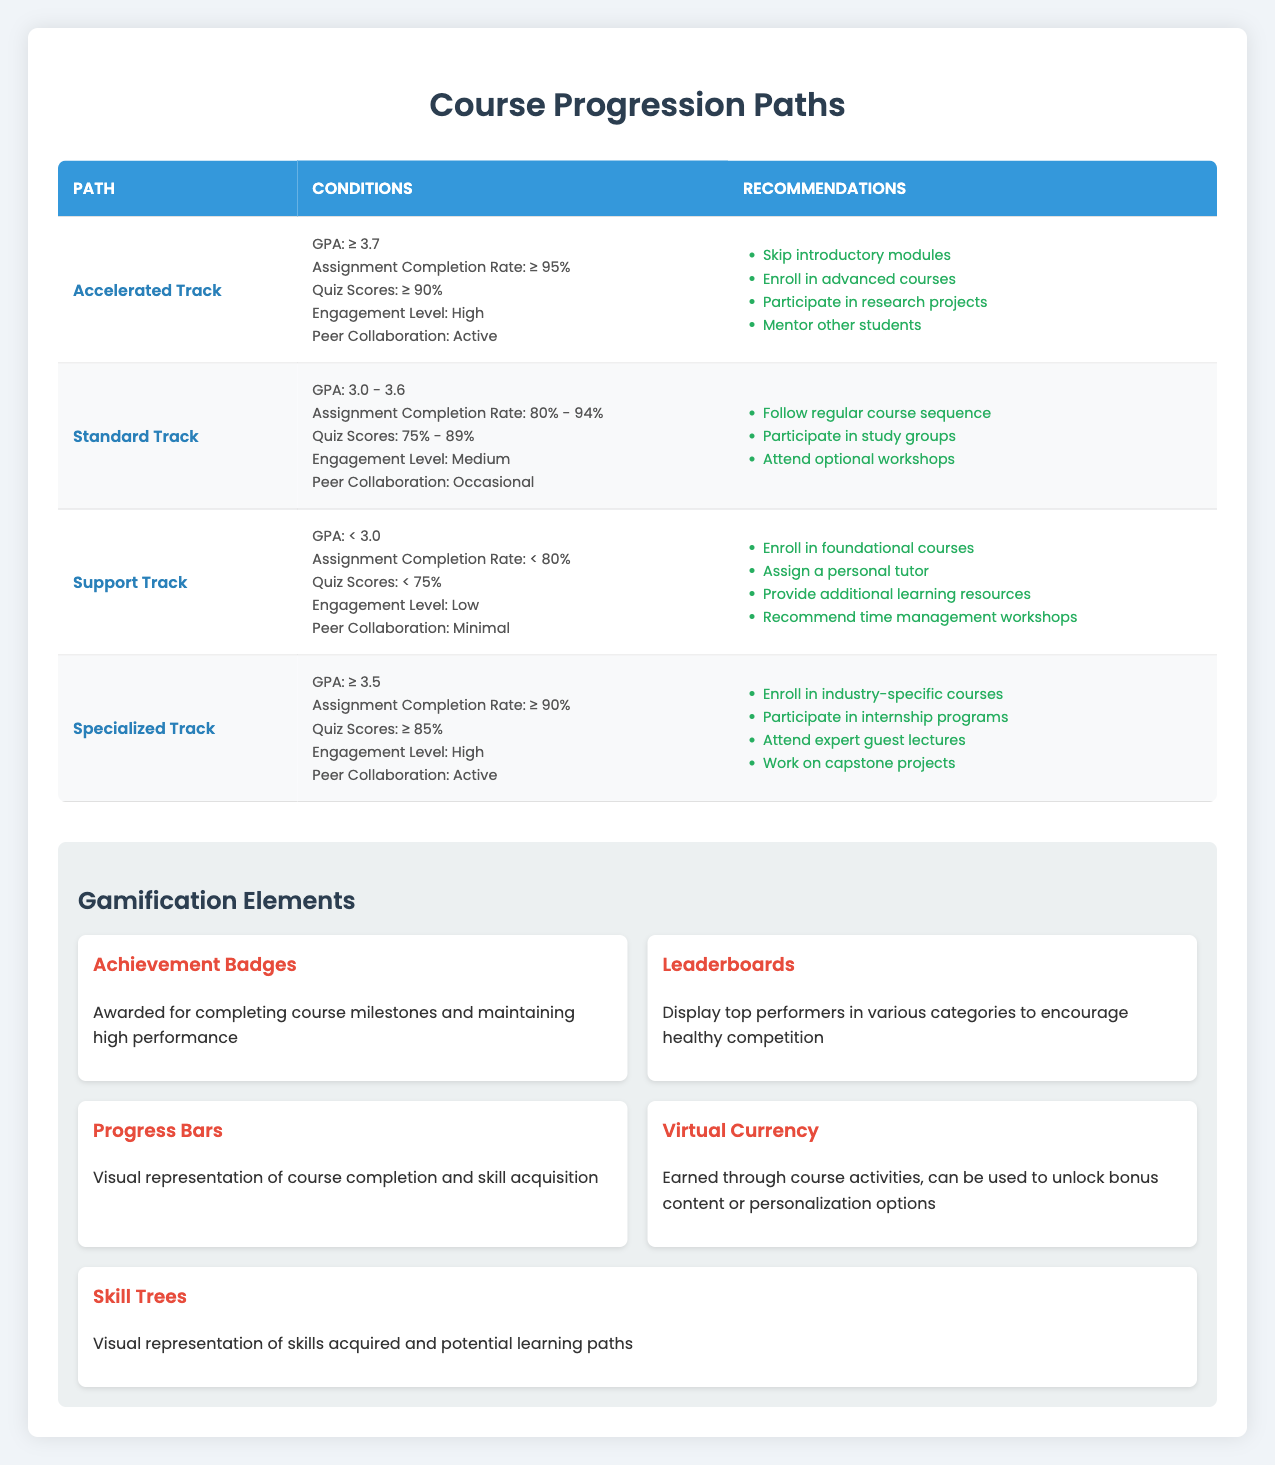What are the conditions for the Support Track? The conditions for the Support Track include a GPA of less than 3.0, an Assignment Completion Rate of less than 80%, Quiz Scores below 75%, a Low Engagement Level, and Minimal Peer Collaboration. These conditions can be easily found in the table under the Support Track row.
Answer: GPA: < 3.0, Assignment Completion Rate: < 80%, Quiz Scores: < 75%, Engagement Level: Low, Peer Collaboration: Minimal Which track has the highest GPA requirement? Looking at the table, the Accelerated Track has a GPA requirement of 3.7 or higher, while the Specialized Track requires a GPA of at least 3.5. The Support Track has a lower threshold of less than 3.0. Therefore, the Accelerated Track has the highest GPA requirement.
Answer: Accelerated Track Is Active Peer Collaboration a condition for the Standard Track? Referring to the table, the Standard Track specifies that Peer Collaboration must be Occasional, not Active. Therefore, the statement is false.
Answer: No What recommendations are made for students on the Accelerated Track? The recommendations for the Accelerated Track, as listed in the table, include skipping introductory modules, enrolling in advanced courses, participating in research projects, and mentoring other students. These actions are all specified in the recommendations column for that track.
Answer: Skip introductory modules, enroll in advanced courses, participate in research projects, mentor other students How many tracks recommend enrolling in industry-specific courses? By reviewing the table, only the Specialized Track explicitly recommends enrolling in industry-specific courses. There are no other mentions for the other tracks. Thus, there is only one track with this recommendation.
Answer: 1 What is the average Quiz Score requirement across all tracks? To find the average Quiz Score requirement, we should consider the values: Accelerated Track ≥ 90%, Standard Track 75% - 89%, Support Track < 75%, Specialized Track ≥ 85%. By assigning values for easy calculation, we could represent them as (90 + 75 + 74 + 85) / 4 = 81. Each range contributes to this calculation towards the average %. Therefore, the average is 81.25.
Answer: 81.25 Is a personal tutor recommended for the Specialized Track? Looking at the recommendations for the Specialized Track, the suggestions include enrolling in industry-specific courses, participating in internship programs, attending guest lectures, and working on capstone projects. A personal tutor is only mentioned under the Support Track recommendations, indicating that the statement is false.
Answer: No Which track has the least strict conditions for both engagement level and GPA? Upon reviewing the table, the Support Track has the least strict conditions with a Low Engagement Level and a GPA of less than 3.0. Comparing it with the other tracks, it has the lowest requirements overall for both metrics.
Answer: Support Track What conditions lead to a recommendation for attending optional workshops? The table indicates that attending optional workshops is recommended for the Standard Track. This track requires a GPA between 3.0 and 3.6, an Assignment Completion Rate between 80% - 94%, Quiz Scores between 75% - 89%, Medium Engagement Level, and Occasional Peer Collaboration.
Answer: Standard Track 